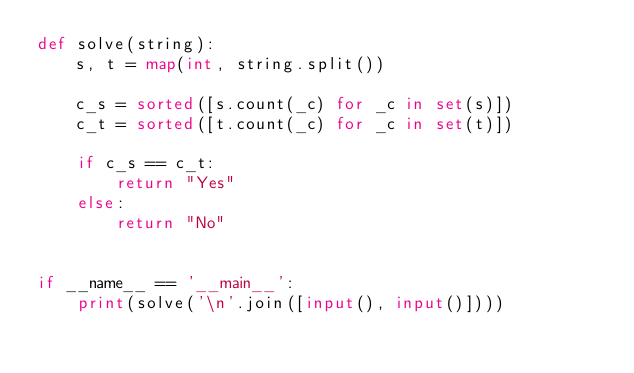<code> <loc_0><loc_0><loc_500><loc_500><_Python_>def solve(string):
    s, t = map(int, string.split())

    c_s = sorted([s.count(_c) for _c in set(s)])
    c_t = sorted([t.count(_c) for _c in set(t)])

    if c_s == c_t:
        return "Yes"
    else:
        return "No"


if __name__ == '__main__':
    print(solve('\n'.join([input(), input()])))
</code> 